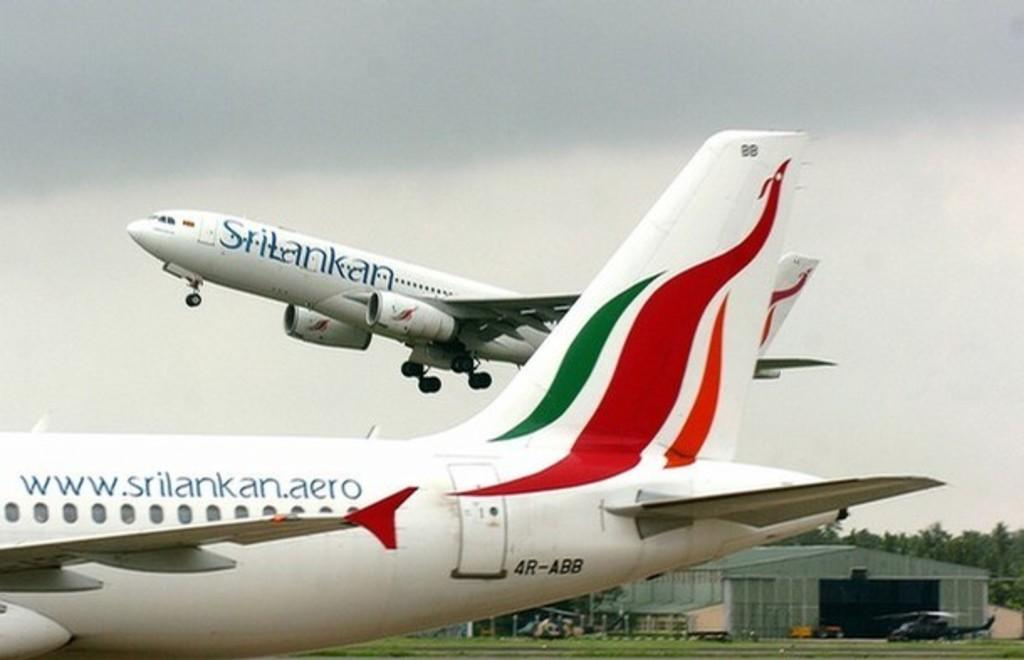<image>
Give a short and clear explanation of the subsequent image. A srilankan jet is sitting on a runway while another plane is taking off. 